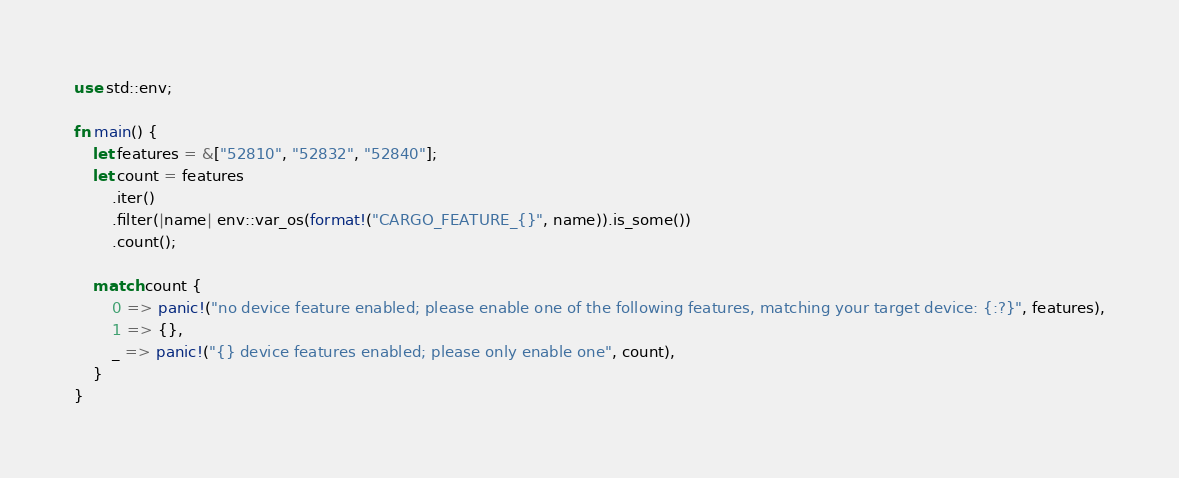<code> <loc_0><loc_0><loc_500><loc_500><_Rust_>use std::env;

fn main() {
    let features = &["52810", "52832", "52840"];
    let count = features
        .iter()
        .filter(|name| env::var_os(format!("CARGO_FEATURE_{}", name)).is_some())
        .count();

    match count {
        0 => panic!("no device feature enabled; please enable one of the following features, matching your target device: {:?}", features),
        1 => {},
        _ => panic!("{} device features enabled; please only enable one", count),
    }
}
</code> 